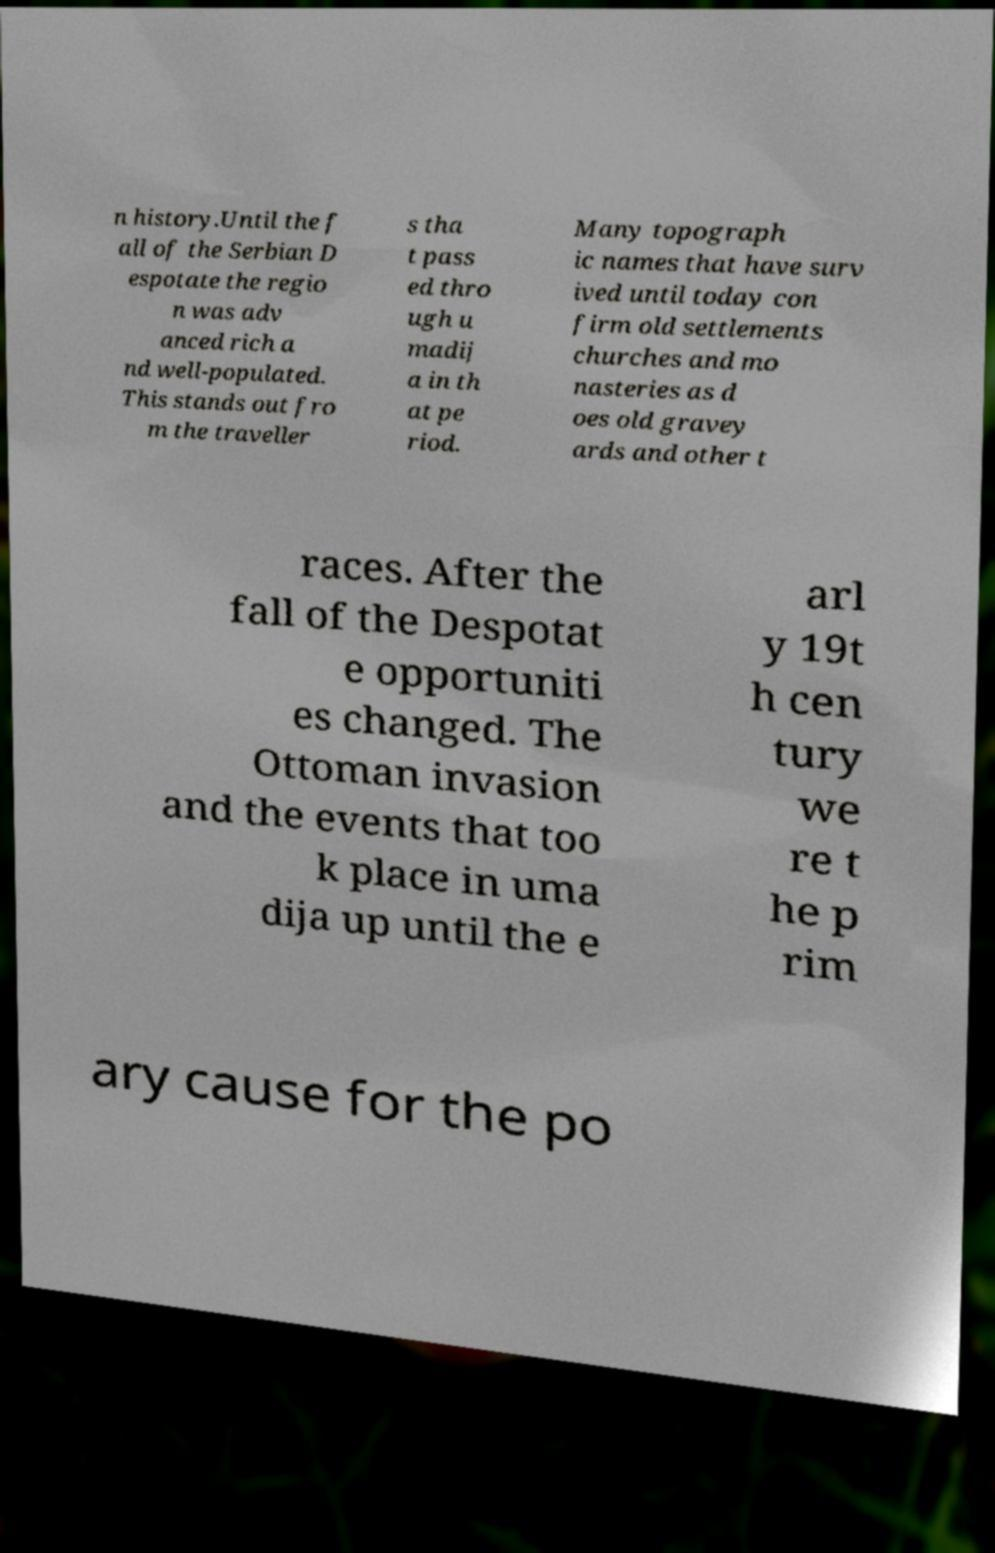Can you read and provide the text displayed in the image?This photo seems to have some interesting text. Can you extract and type it out for me? n history.Until the f all of the Serbian D espotate the regio n was adv anced rich a nd well-populated. This stands out fro m the traveller s tha t pass ed thro ugh u madij a in th at pe riod. Many topograph ic names that have surv ived until today con firm old settlements churches and mo nasteries as d oes old gravey ards and other t races. After the fall of the Despotat e opportuniti es changed. The Ottoman invasion and the events that too k place in uma dija up until the e arl y 19t h cen tury we re t he p rim ary cause for the po 